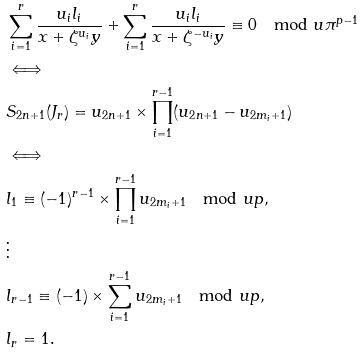<formula> <loc_0><loc_0><loc_500><loc_500>& \sum _ { i = 1 } ^ { r } \frac { u _ { i } l _ { i } } { x + \zeta ^ { u _ { i } } y } + \sum _ { i = 1 } ^ { r } \frac { u _ { i } l _ { i } } { x + \zeta ^ { - u _ { i } } y } \equiv 0 \mod u \pi ^ { p - 1 } \\ & \Longleftrightarrow \\ & S _ { 2 n + 1 } ( J _ { r } ) = u _ { 2 n + 1 } \times \prod _ { i = 1 } ^ { r - 1 } ( u _ { 2 n + 1 } - u _ { 2 m _ { i } + 1 } ) \\ & \Longleftrightarrow \\ & l _ { 1 } \equiv ( - 1 ) ^ { r - 1 } \times \prod _ { i = 1 } ^ { r - 1 } u _ { 2 m _ { i } + 1 } \mod u p , \\ & \vdots \\ & l _ { r - 1 } \equiv ( - 1 ) \times \sum _ { i = 1 } ^ { r - 1 } u _ { 2 m _ { i } + 1 } \mod u p , \\ & l _ { r } = 1 .</formula> 